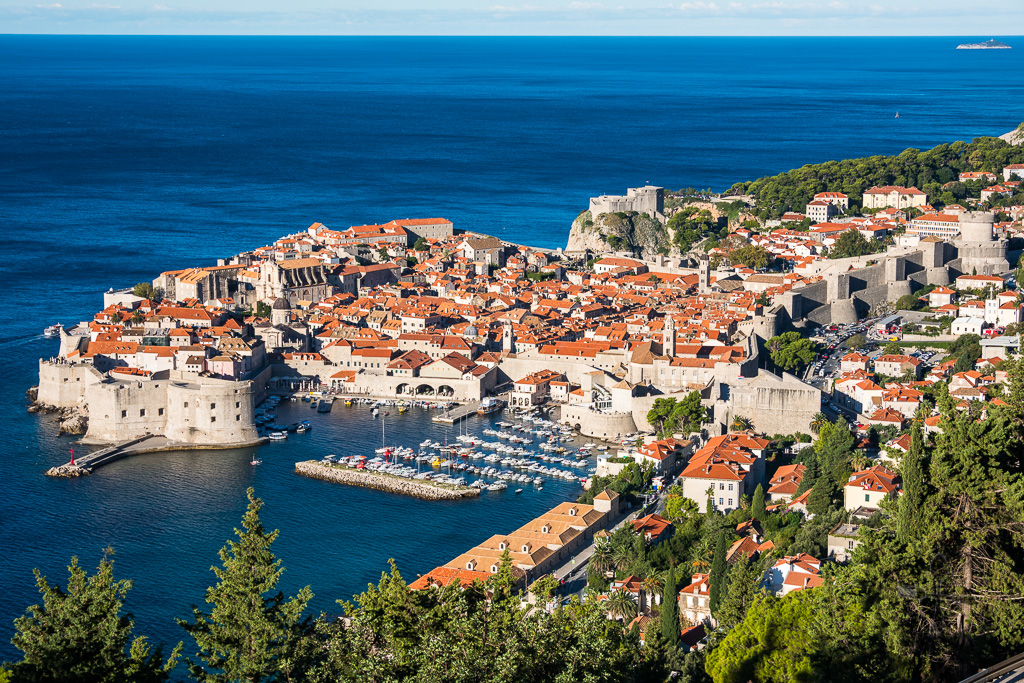What do you see happening in this image? The image showcases the stunning ancient city walls of Dubrovnik in Croatia from a high viewpoint. The medieval stone walls, fortified with towers, encase an array of white-walled buildings topped with vibrant orange roofs. Interspersed with greenery, the cityscape contrasts beautifully with the deep blue of the Adriatic Sea. A cluster of boats dot the nearby harbor, hinting at the bustling maritime activity, while a cruise ship in the distance alludes to Dubrovnik's allure as a major tourist destination. The scene exudes a captivating blend of history, architecture, and scenic beauty. 